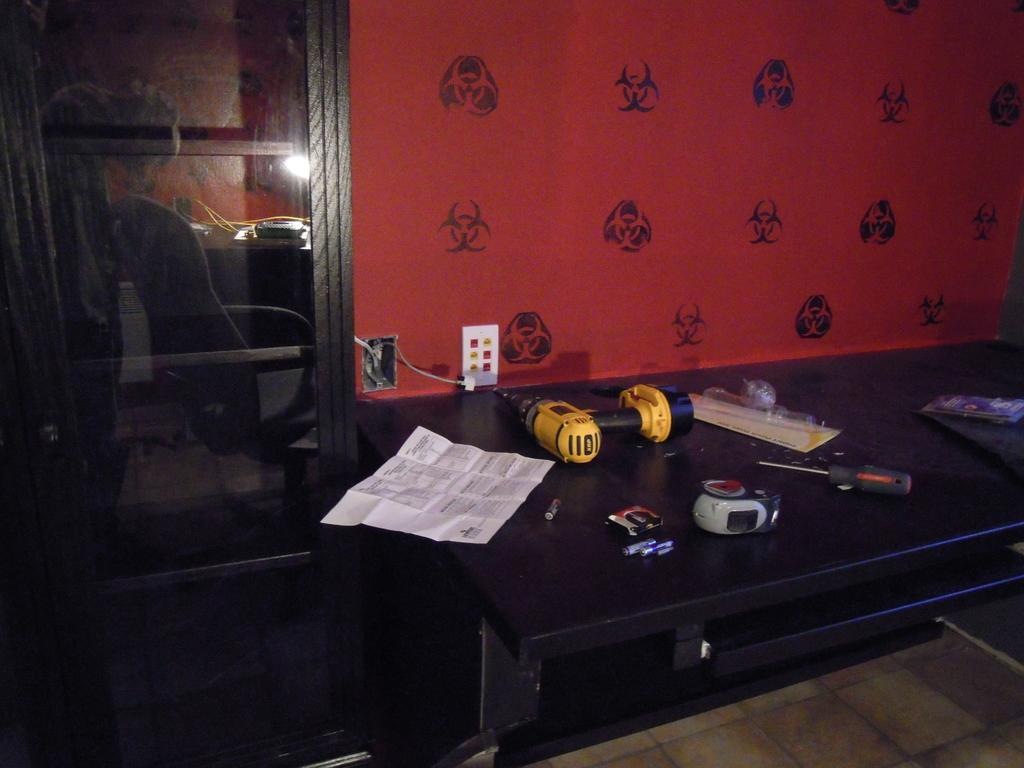What can be seen on the desk in the foreground of the image? There are tools on a desk in the foreground area of the image. What else is on the desk besides the tools? There is a paper on the desk, and there are other items on the desk as well. What is located on the left side of the image? There appears to be a rack on the left side of the image. What can be seen in the background of the image? There is a wall visible in the background of the image. Can you see a donkey or squirrel interacting with the tools on the desk in the image? No, there are no animals, such as a donkey or squirrel, present in the image. What type of crush is the person experiencing in the image? There is no person or indication of a crush in the image; it primarily features a desk with tools and other items. 